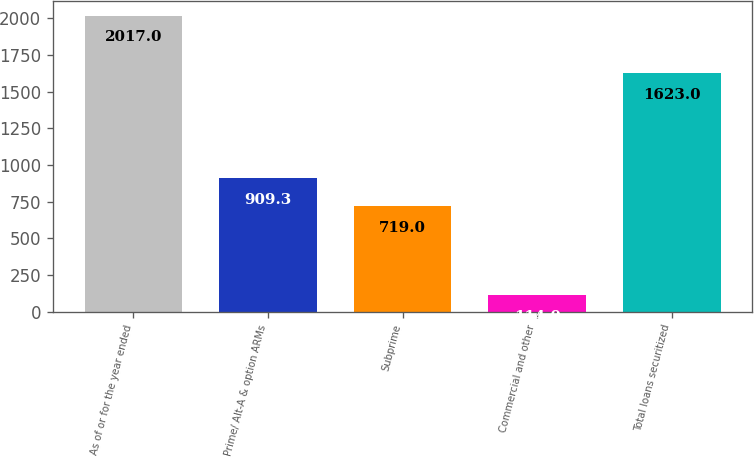Convert chart to OTSL. <chart><loc_0><loc_0><loc_500><loc_500><bar_chart><fcel>As of or for the year ended<fcel>Prime/ Alt-A & option ARMs<fcel>Subprime<fcel>Commercial and other<fcel>Total loans securitized<nl><fcel>2017<fcel>909.3<fcel>719<fcel>114<fcel>1623<nl></chart> 